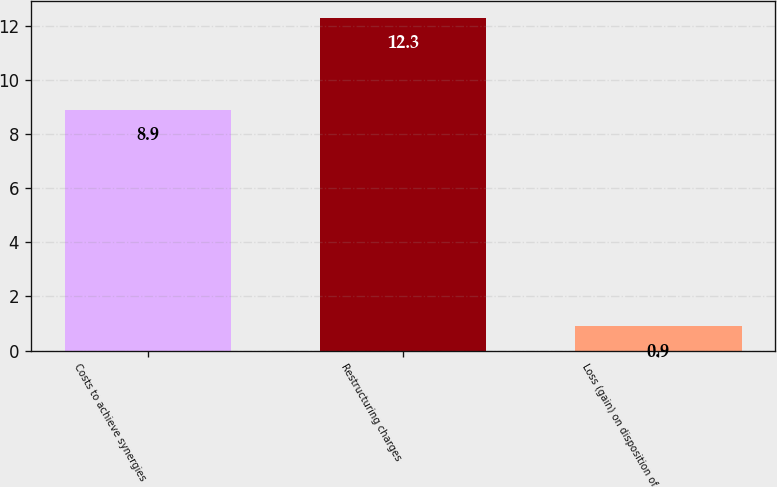<chart> <loc_0><loc_0><loc_500><loc_500><bar_chart><fcel>Costs to achieve synergies<fcel>Restructuring charges<fcel>Loss (gain) on disposition of<nl><fcel>8.9<fcel>12.3<fcel>0.9<nl></chart> 